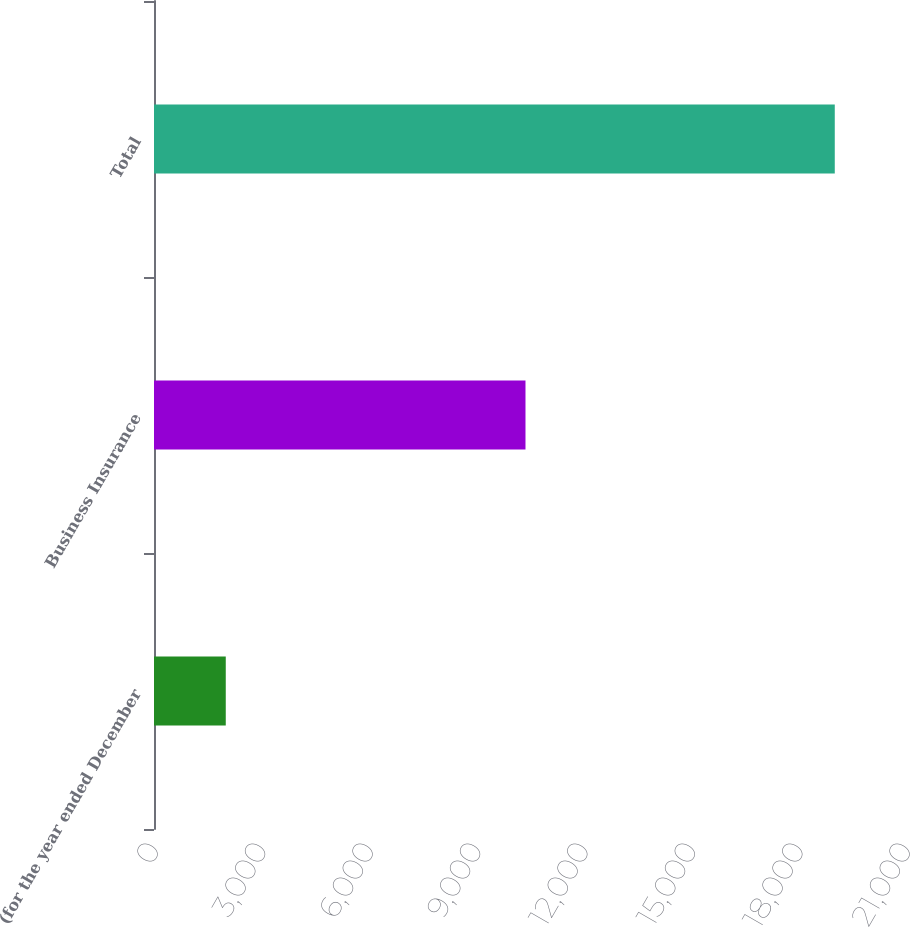Convert chart. <chart><loc_0><loc_0><loc_500><loc_500><bar_chart><fcel>(for the year ended December<fcel>Business Insurance<fcel>Total<nl><fcel>2004<fcel>10374<fcel>19011<nl></chart> 